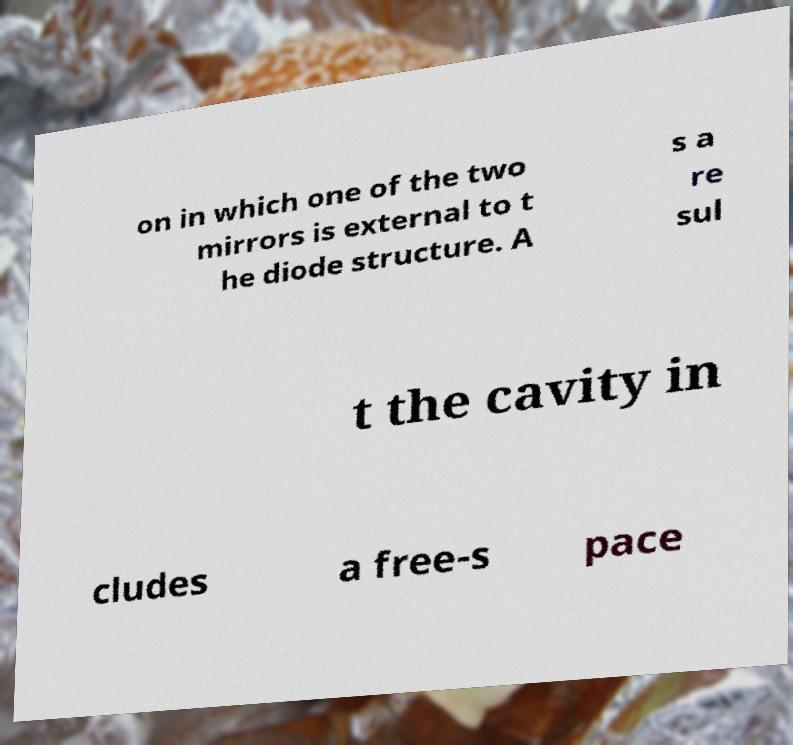I need the written content from this picture converted into text. Can you do that? on in which one of the two mirrors is external to t he diode structure. A s a re sul t the cavity in cludes a free-s pace 